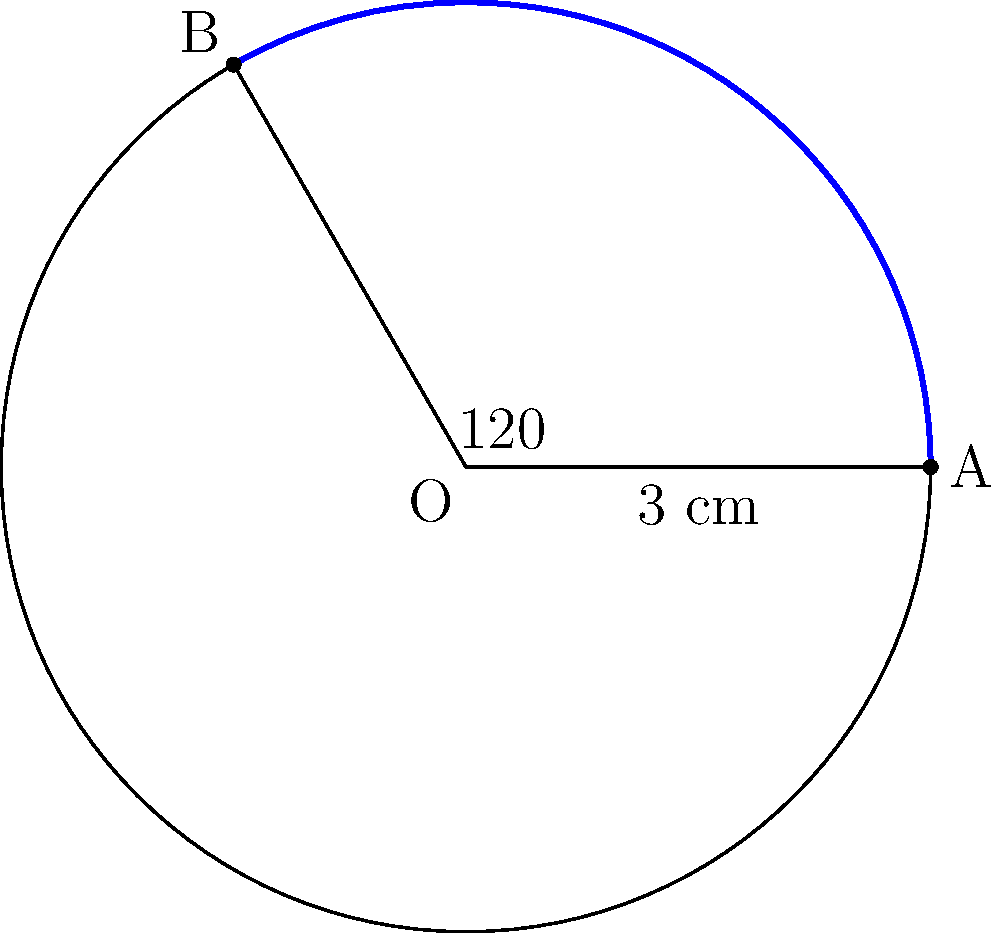Imagine you're planning a curved pathway for your garden that follows the shape of a circular flower bed. If the flower bed has a radius of 3 cm and you want the pathway to cover an arc of 120°, what would be the length of the curved pathway? Let's solve this step-by-step:

1) We know that the formula for arc length is:
   $$s = r\theta$$
   where $s$ is the arc length, $r$ is the radius, and $\theta$ is the central angle in radians.

2) We're given:
   - Radius $(r) = 3$ cm
   - Central angle = 120°

3) We need to convert the angle from degrees to radians:
   $$\theta = 120° \times \frac{\pi}{180°} = \frac{2\pi}{3}$$ radians

4) Now we can substitute these values into our formula:
   $$s = r\theta = 3 \times \frac{2\pi}{3} = 2\pi$$ cm

5) If we want to calculate this numerically:
   $$2\pi \approx 2 \times 3.14159 \approx 6.28$$ cm

So, the length of your curved garden pathway would be $2\pi$ cm or approximately 6.28 cm.
Answer: $2\pi$ cm (≈ 6.28 cm) 